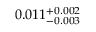Convert formula to latex. <formula><loc_0><loc_0><loc_500><loc_500>0 . 0 1 1 _ { - 0 . 0 0 3 } ^ { + 0 . 0 0 2 }</formula> 